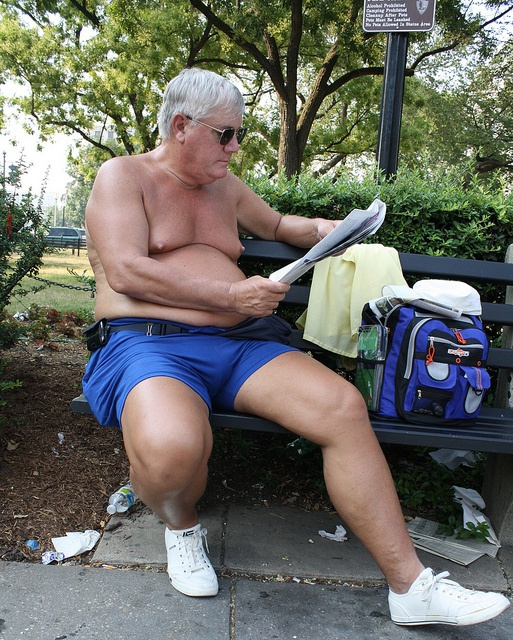Describe the objects in this image and their specific colors. I can see people in darkgreen, gray, darkgray, and lightgray tones, backpack in darkgreen, black, white, navy, and darkblue tones, bench in darkgreen, black, darkblue, navy, and gray tones, car in darkgreen, gray, blue, and black tones, and bottle in darkgreen, darkgray, gray, and lightblue tones in this image. 